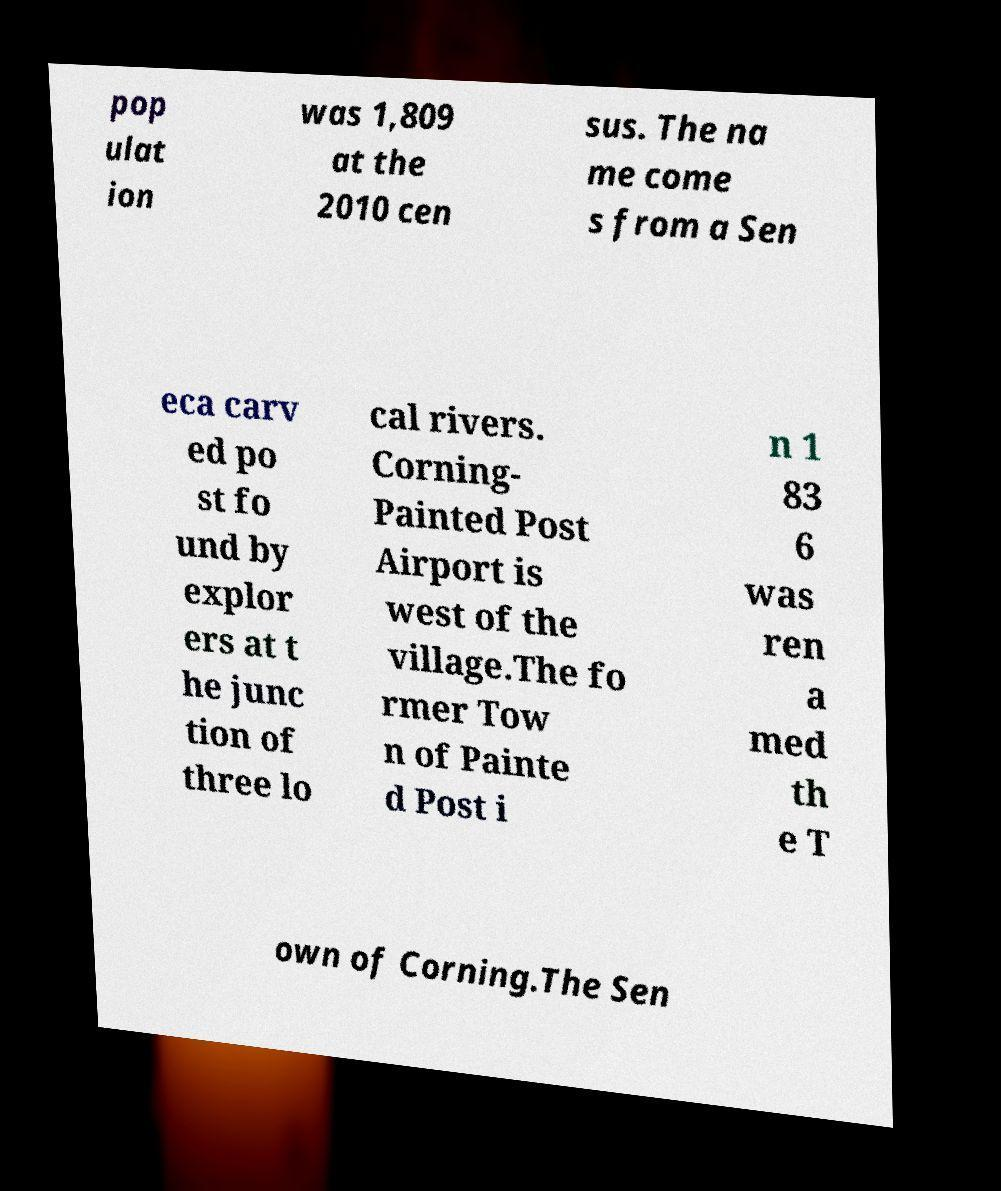Could you assist in decoding the text presented in this image and type it out clearly? pop ulat ion was 1,809 at the 2010 cen sus. The na me come s from a Sen eca carv ed po st fo und by explor ers at t he junc tion of three lo cal rivers. Corning- Painted Post Airport is west of the village.The fo rmer Tow n of Painte d Post i n 1 83 6 was ren a med th e T own of Corning.The Sen 